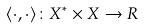Convert formula to latex. <formula><loc_0><loc_0><loc_500><loc_500>\langle \cdot , \cdot \rangle \colon X ^ { * } \times X \rightarrow R</formula> 